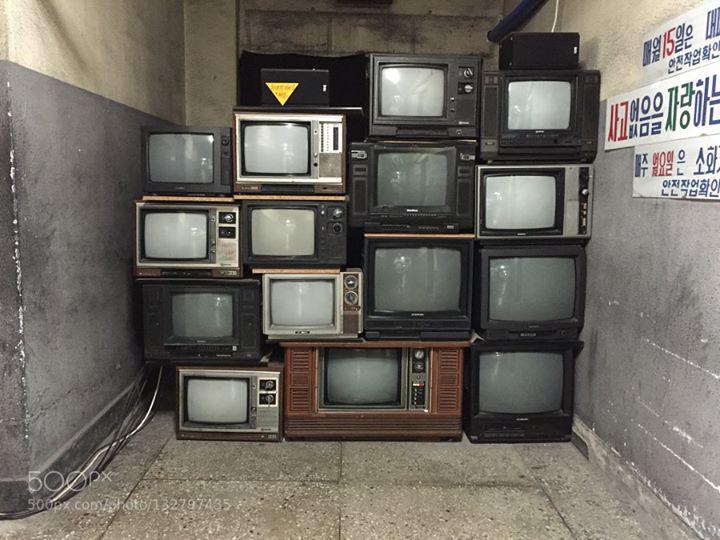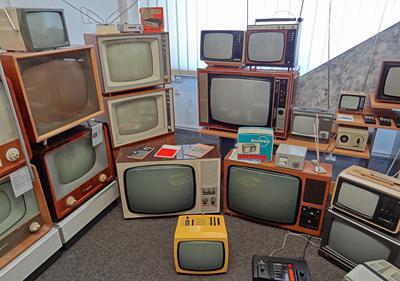The first image is the image on the left, the second image is the image on the right. Assess this claim about the two images: "Each image contains at least one stack that includes multiple different models of old-fashioned TV sets.". Correct or not? Answer yes or no. Yes. 